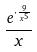<formula> <loc_0><loc_0><loc_500><loc_500>\frac { e ^ { \cdot \frac { 9 } { x ^ { 5 } } } } { x }</formula> 